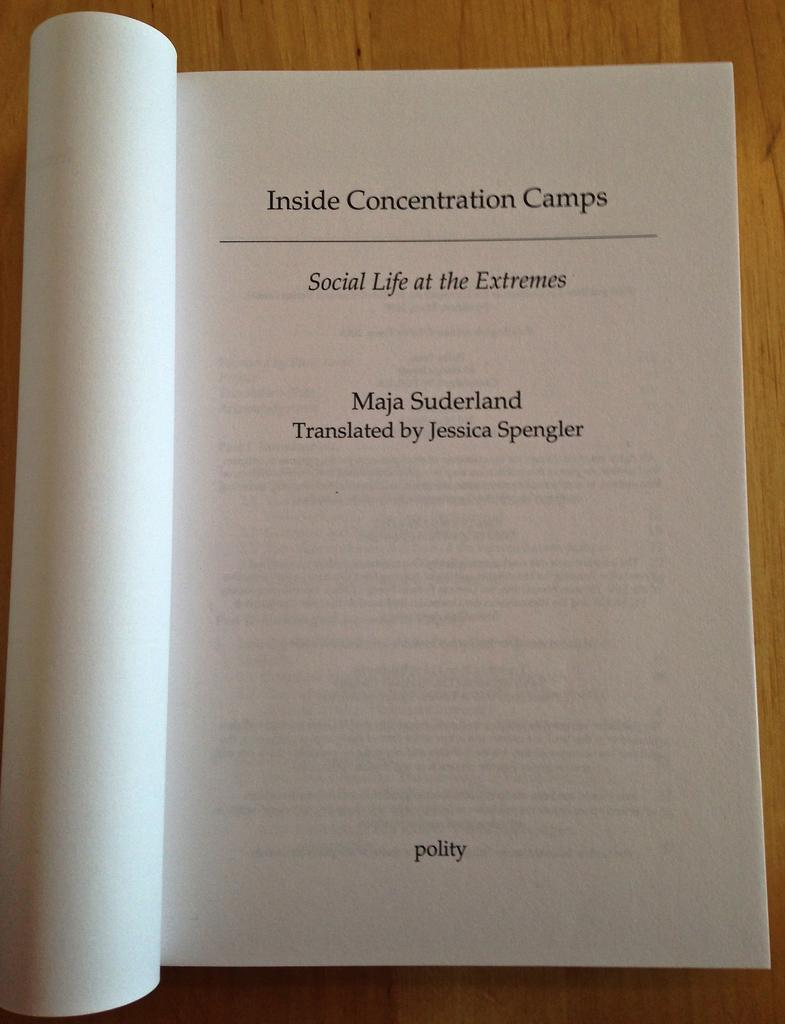<image>
Render a clear and concise summary of the photo. The opening page of the book Inside Concentration Camps. 